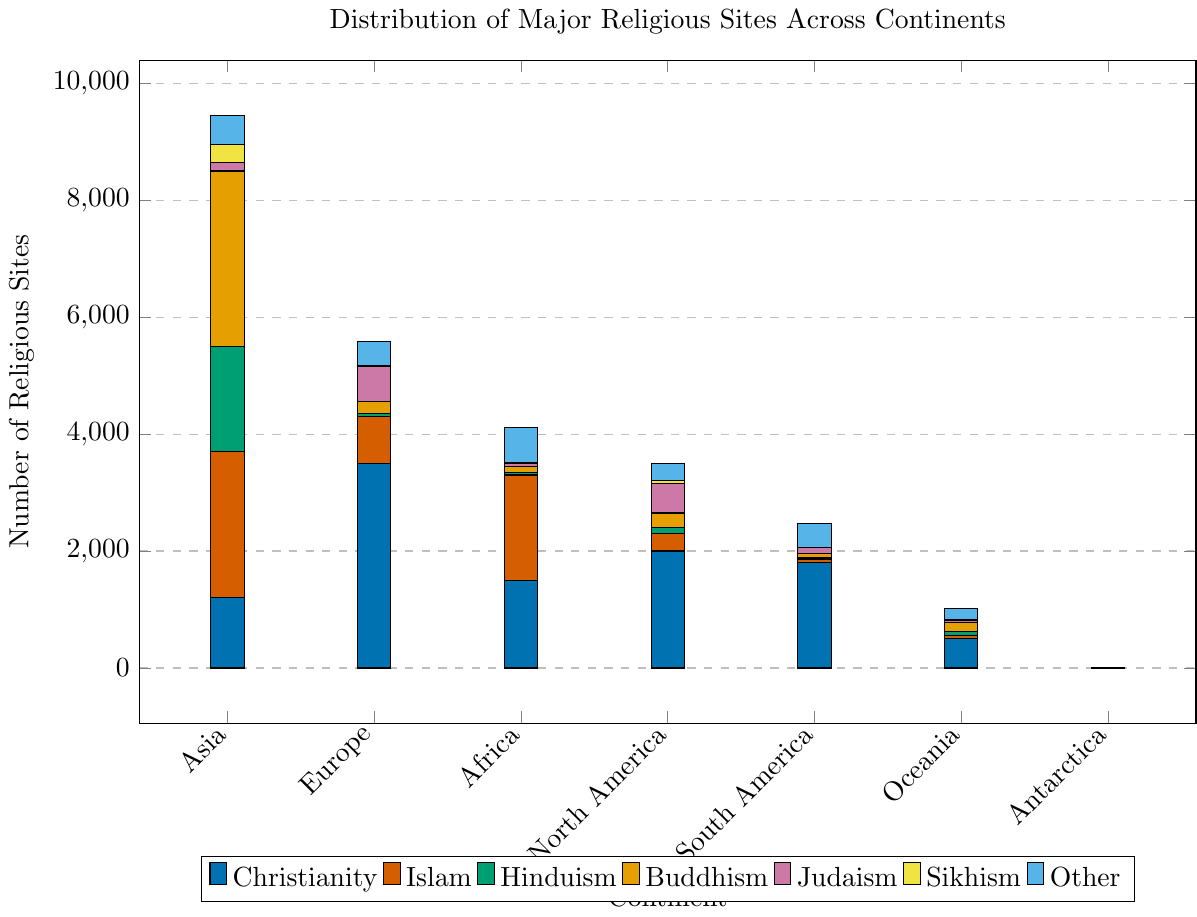Which continent has the highest number of Christian sites? To find the answer, look at the blue bars representing Christian sites in each continent and identify the tallest bar. Europe has the highest number of Christian sites.
Answer: Europe How many Buddhist sites are there in Asia, and how does it compare to North America? First, find the height of the yellow bar in Asia and North America. Asia has 3000 Buddhist sites, while North America has 250. Comparing the two, Asia has 3000 - 250 = 2750 more Buddhist sites than North America.
Answer: 3000; 2750 more Which continent has the least number of Hindu sites? Look at the green bars representing Hindu sites in each continent and find the shortest one. Europe, Africa, and Antarctica all have short green bars, but Antarctica has 0 Hindu sites.
Answer: Antarctica What is the total number of religious sites in Antarctica? Sum up the heights of all the bars in Antarctica. There are 2 Christian sites, 0 sites for other faiths except 1 for Other category. So, total number of sites is 2 + 1 = 3.
Answer: 3 In how many continents does Judaism have more religious sites than Sikhism? Compare the purple bars (Judaism) and orange bars (Sikhism) across continents. Africa, Europe, North America, and South America have more sites for Judaism than Sikhism. That's 4 continents.
Answer: 4 Which faith has the most sites in Africa? Observe the highest bar in Africa. The red bar (representing Islam) is the tallest, indicating that Islam has the most sites in Africa.
Answer: Islam What is the total number of Christian and Islamic sites in Europe? Add the number of Christian sites (3500) and Islamic sites (800) in Europe. The total is 3500 + 800 = 4300.
Answer: 4300 How does the number of Sikh sites in South America compare to Oceania? Compare the height of the orange bars in South America and Oceania. South America has 5 Sikh sites, while Oceania has 10 Sikh sites. Oceania has 10 - 5 = 5 more Sikh sites than South America.
Answer: Oceania; 5 more Which continent has the most diverse distribution of religious sites, considering the variety of faiths? Assess which continent has all or nearly all colored bars (categories of faith). Asia and North America have all bars, but Asia has higher quantities and a balanced distribution.
Answer: Asia 